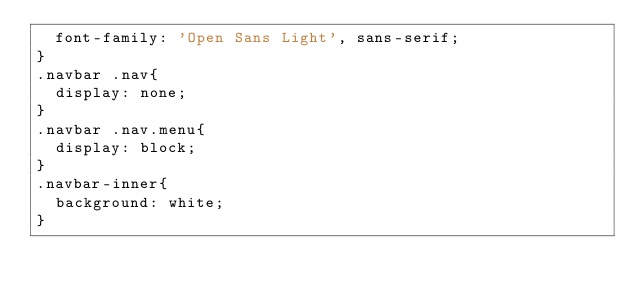<code> <loc_0><loc_0><loc_500><loc_500><_CSS_>  font-family: 'Open Sans Light', sans-serif;
}
.navbar .nav{
  display: none;
}
.navbar .nav.menu{
  display: block;
}
.navbar-inner{
  background: white;
}

</code> 